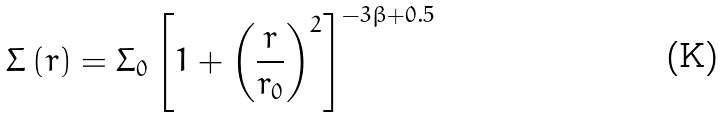<formula> <loc_0><loc_0><loc_500><loc_500>\Sigma \left ( r \right ) = \Sigma _ { 0 } \left [ 1 + \left ( \frac { r } { r _ { 0 } } \right ) ^ { 2 } \right ] ^ { - 3 \beta + 0 . 5 }</formula> 